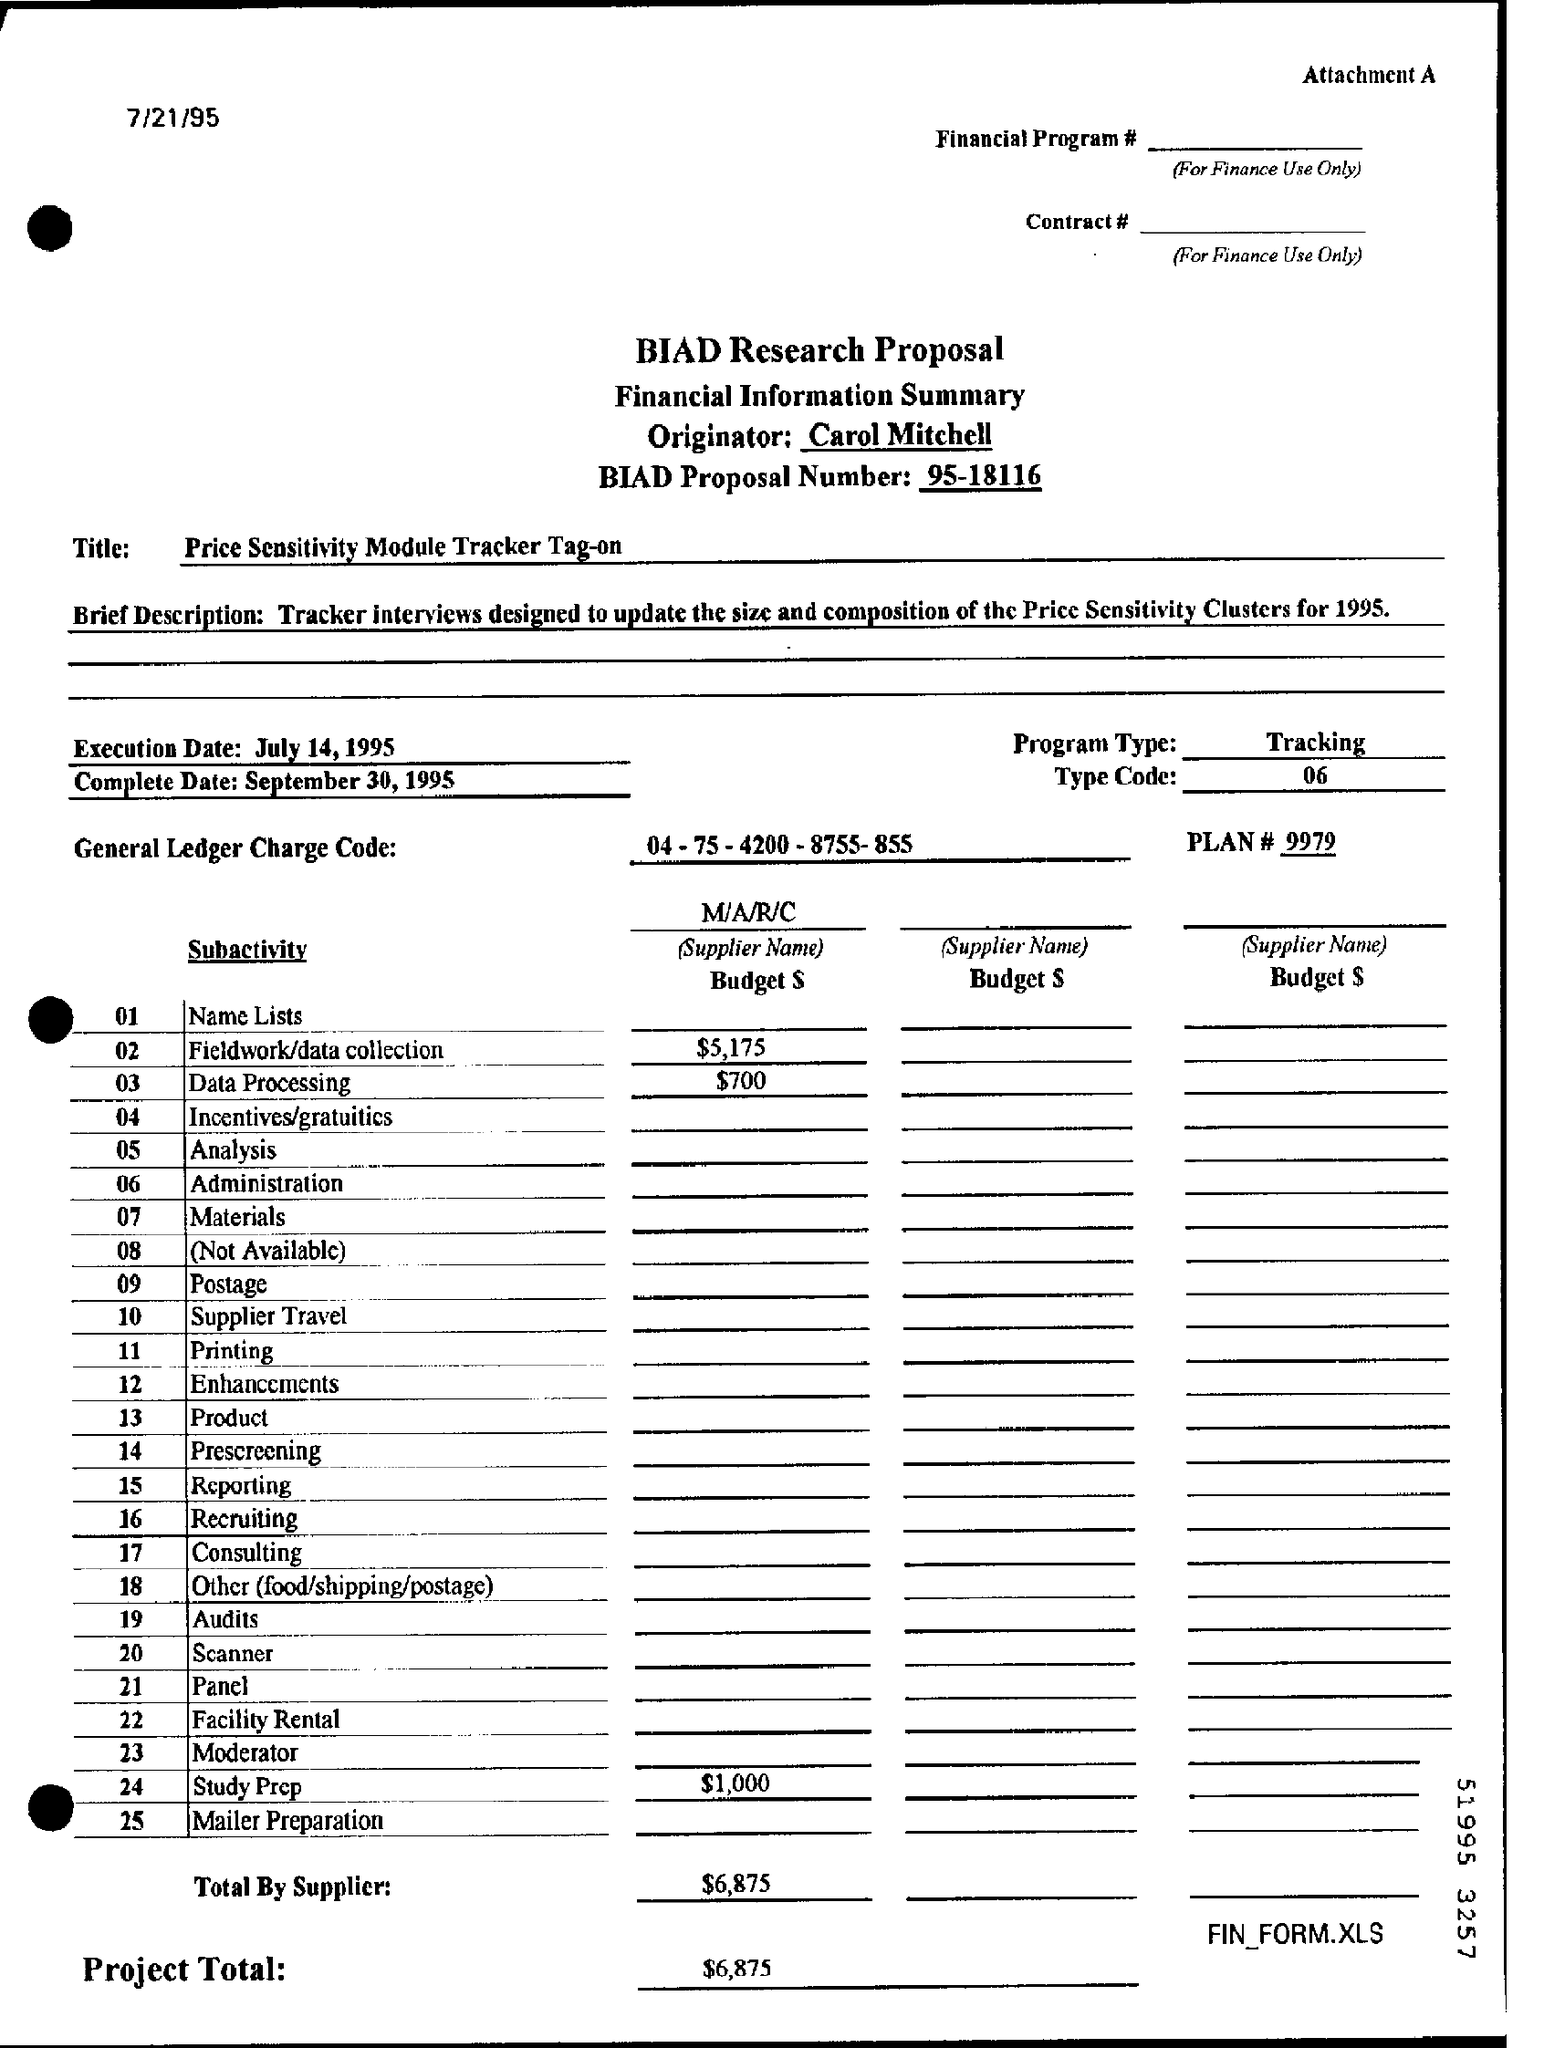What is the name of the proposal ?
Your answer should be compact. BIAD Research Proposal. What is the biad proposal number ?
Ensure brevity in your answer.  95-18116. What is the title mentioned in the proposal ?
Your answer should be compact. Price sensitivity module tracker tag-on. What is the program type mentioned in the proposal ?
Give a very brief answer. Tracking. What is the type code number mentioned in the proposal ?
Give a very brief answer. 06. What is the plan number mentioned in the proposal ?
Your answer should be compact. 9979. What is the amount of the project total mentioned in the proposal ?
Give a very brief answer. $6,875. 